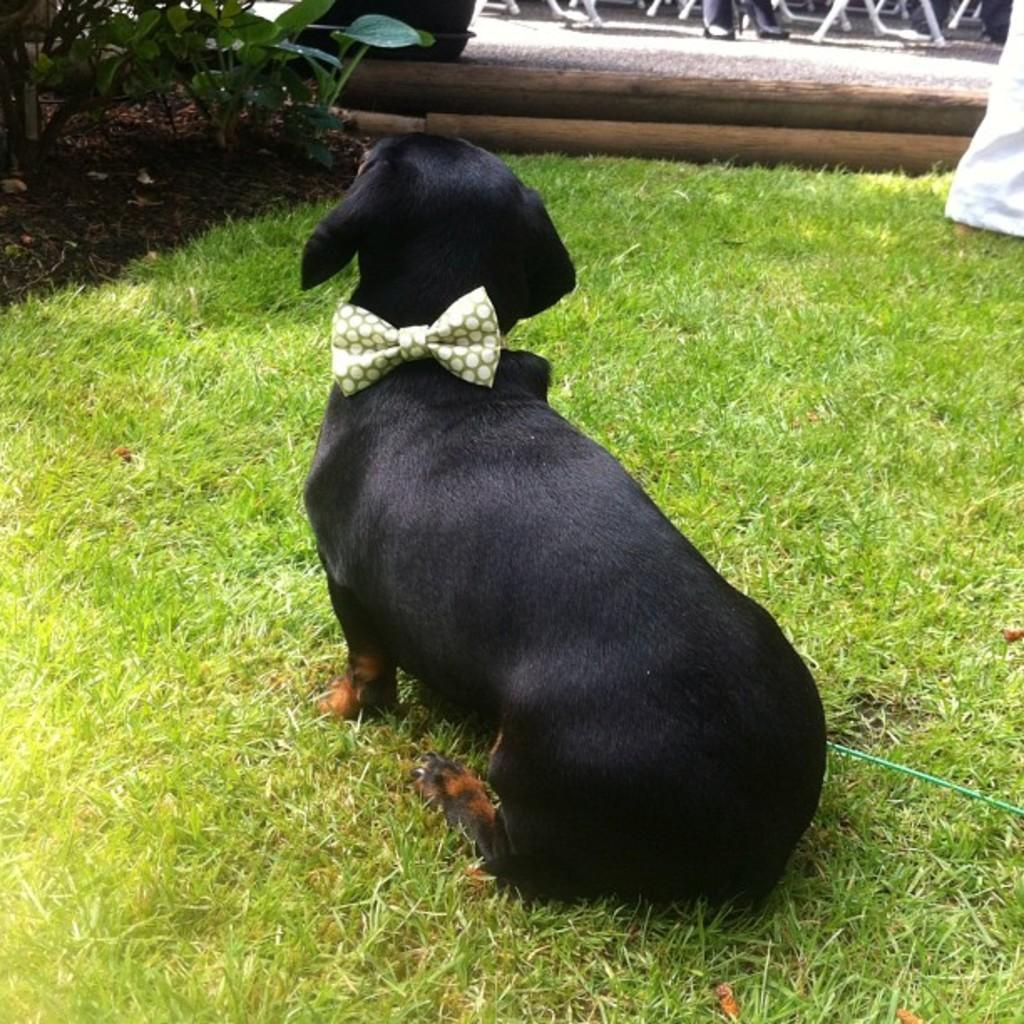What animal can be seen in the image? There is a dog in the image. How is the dog dressed in the image? The dog is wearing a bow tie. Where is the dog located in the image? The dog is on the grass. What type of vegetation is on the right side of the image? There are plants on the right side of the image. What objects can be seen on the ground in the image? There are wooden sticks on the ground in the image. What type of fuel is the dog using to power its movements in the image? The dog is not using any fuel to power its movements in the image; it is stationary on the grass. Can you see a net in the image? There is no net present in the image. 